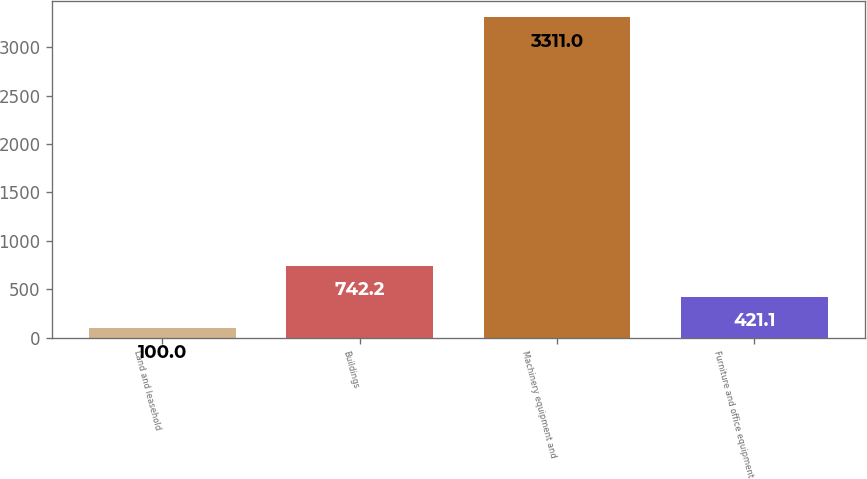Convert chart. <chart><loc_0><loc_0><loc_500><loc_500><bar_chart><fcel>Land and leasehold<fcel>Buildings<fcel>Machinery equipment and<fcel>Furniture and office equipment<nl><fcel>100<fcel>742.2<fcel>3311<fcel>421.1<nl></chart> 